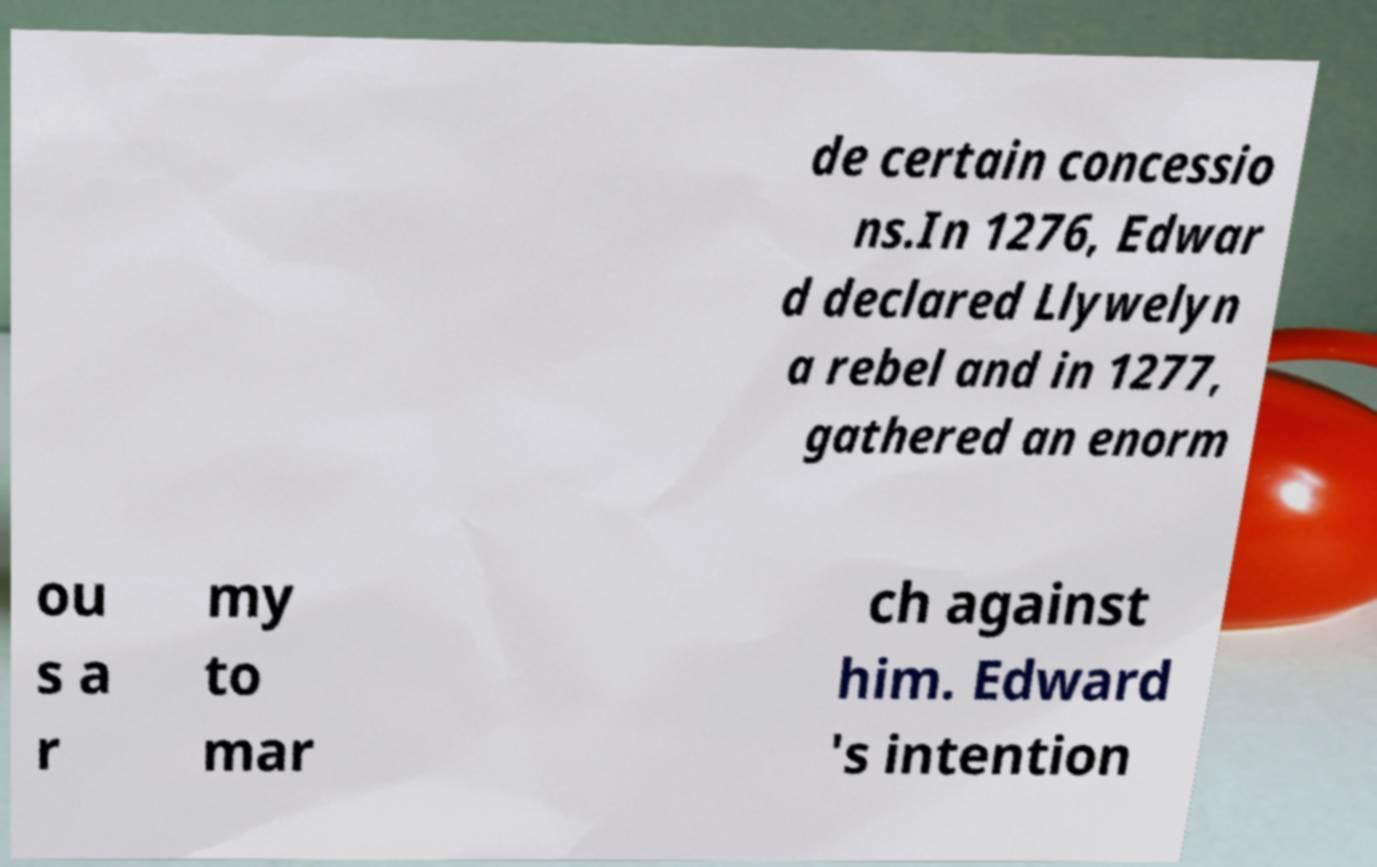Could you extract and type out the text from this image? de certain concessio ns.In 1276, Edwar d declared Llywelyn a rebel and in 1277, gathered an enorm ou s a r my to mar ch against him. Edward 's intention 